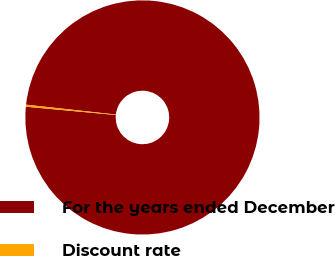<chart> <loc_0><loc_0><loc_500><loc_500><pie_chart><fcel>For the years ended December<fcel>Discount rate<nl><fcel>99.72%<fcel>0.28%<nl></chart> 